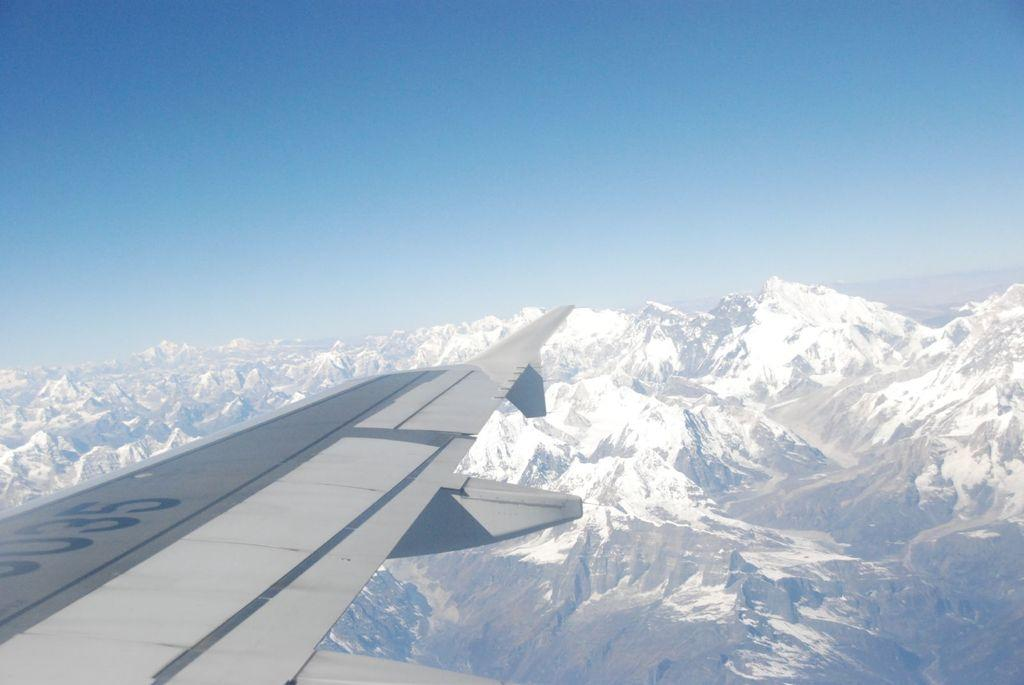<image>
Describe the image concisely. Airplane with a few numbers including 035 in blue. 